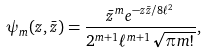Convert formula to latex. <formula><loc_0><loc_0><loc_500><loc_500>\psi _ { m } ( z , \bar { z } ) = \frac { \bar { z } ^ { m } e ^ { - z \bar { z } / 8 \ell ^ { 2 } } } { 2 ^ { m + 1 } \ell ^ { m + 1 } \sqrt { \pi m ! } } ,</formula> 